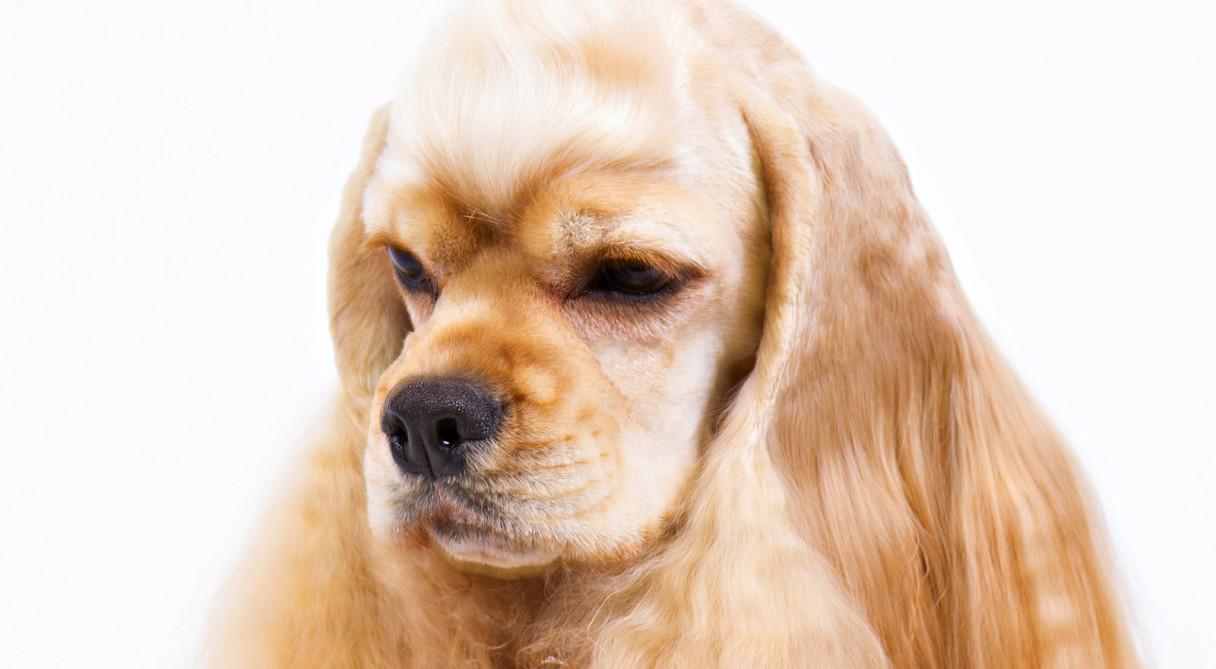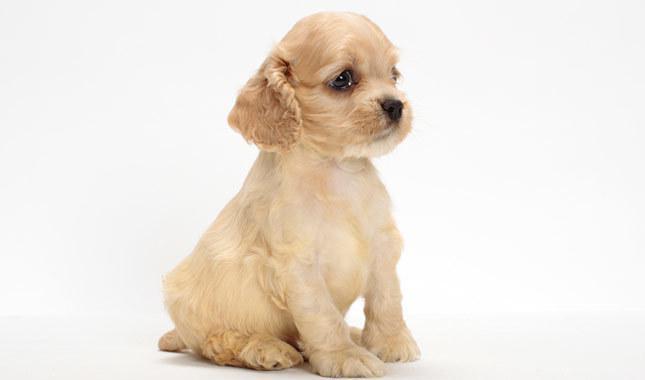The first image is the image on the left, the second image is the image on the right. Evaluate the accuracy of this statement regarding the images: "The dogs on the left image have plain white background.". Is it true? Answer yes or no. Yes. 